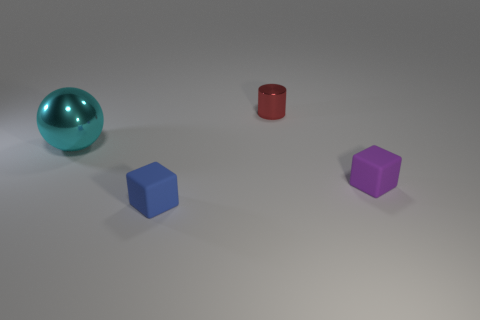What number of things are small blocks that are right of the red shiny thing or tiny cyan rubber things?
Provide a succinct answer. 1. Are there any small brown metallic spheres?
Provide a short and direct response. No. There is a thing that is in front of the big ball and right of the blue object; what shape is it?
Offer a very short reply. Cube. What is the size of the matte object that is on the left side of the small red metal cylinder?
Your answer should be very brief. Small. Is the color of the object that is behind the metallic sphere the same as the large thing?
Offer a very short reply. No. How many small red metallic objects have the same shape as the blue object?
Provide a short and direct response. 0. What number of objects are either tiny objects that are in front of the large cyan object or metal objects that are to the left of the red shiny cylinder?
Keep it short and to the point. 3. How many gray things are either balls or rubber objects?
Provide a short and direct response. 0. There is a thing that is both behind the small purple matte thing and on the right side of the tiny blue cube; what is its material?
Offer a very short reply. Metal. Do the red cylinder and the purple thing have the same material?
Ensure brevity in your answer.  No. 